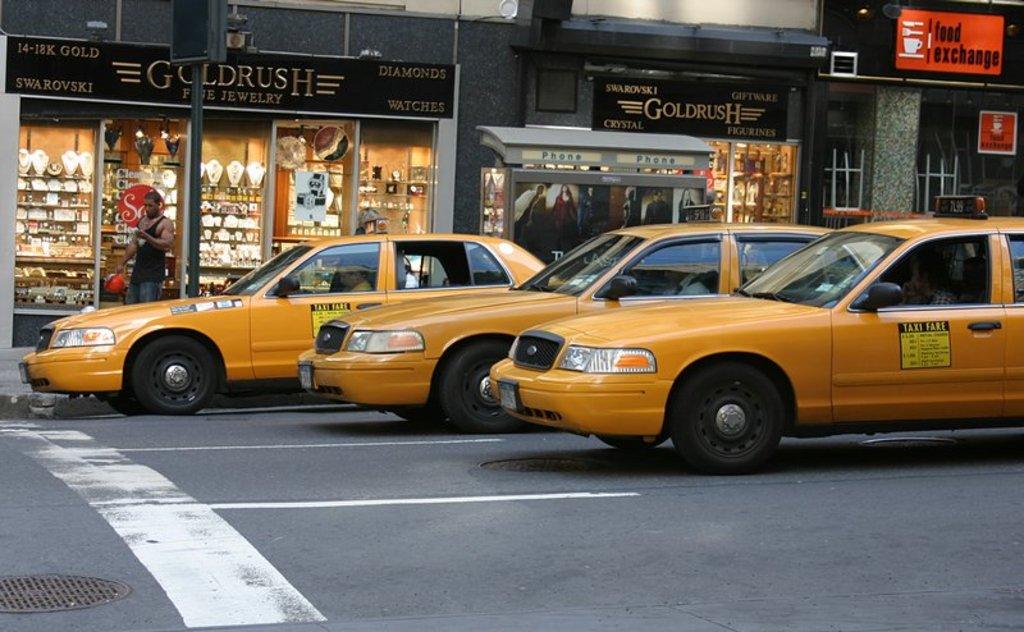What is written on the door of the closest yellow taxi?
Provide a short and direct response. Taxi fare. 